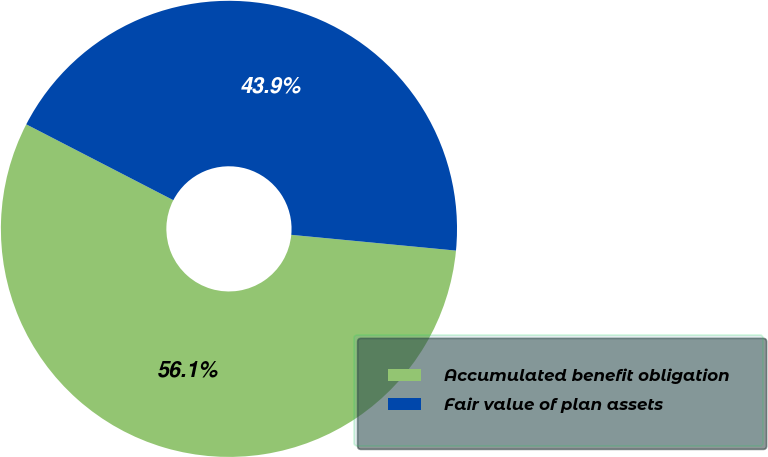<chart> <loc_0><loc_0><loc_500><loc_500><pie_chart><fcel>Accumulated benefit obligation<fcel>Fair value of plan assets<nl><fcel>56.06%<fcel>43.94%<nl></chart> 